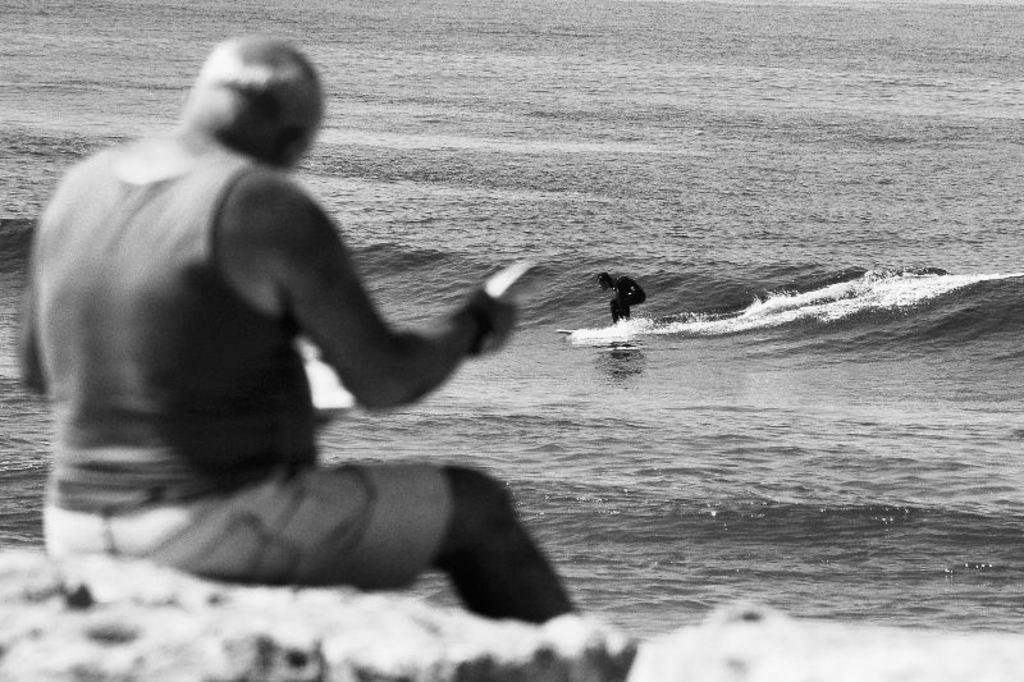What is the man in the image doing? There is a man sitting and holding an object in the image. What activity is the other person engaged in? There is a person riding a surfboard on water in the image. How many geese are swimming alongside the surfboard in the image? There are no geese present in the image; it features a man sitting and holding an object, and a person riding a surfboard on water. 